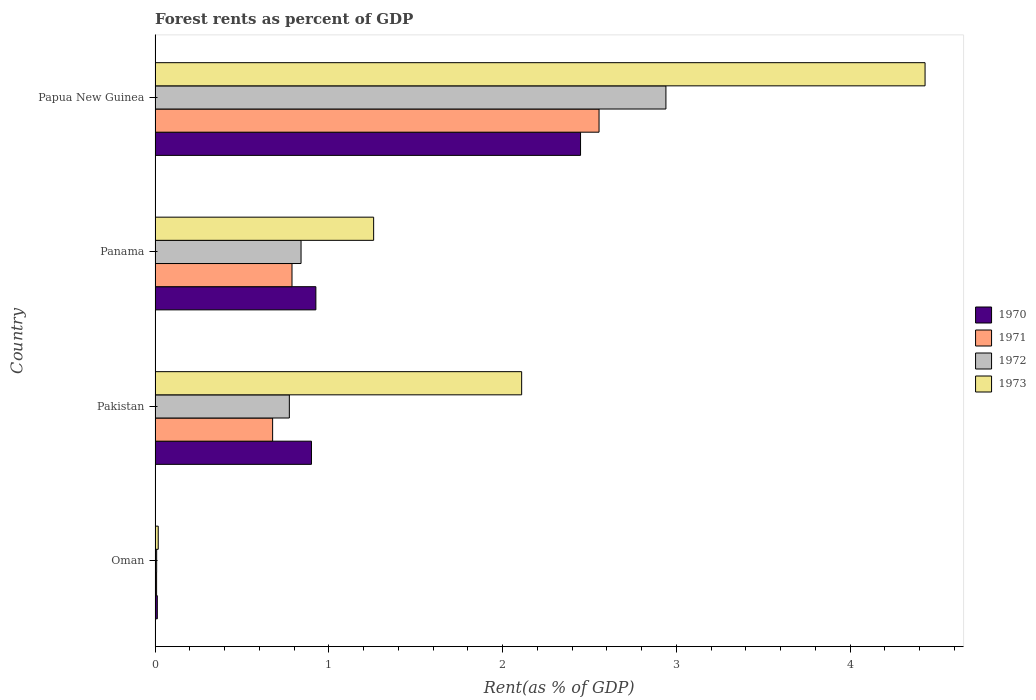How many different coloured bars are there?
Provide a succinct answer. 4. What is the label of the 4th group of bars from the top?
Provide a short and direct response. Oman. In how many cases, is the number of bars for a given country not equal to the number of legend labels?
Make the answer very short. 0. What is the forest rent in 1970 in Pakistan?
Your answer should be compact. 0.9. Across all countries, what is the maximum forest rent in 1972?
Ensure brevity in your answer.  2.94. Across all countries, what is the minimum forest rent in 1971?
Your response must be concise. 0.01. In which country was the forest rent in 1970 maximum?
Give a very brief answer. Papua New Guinea. In which country was the forest rent in 1972 minimum?
Offer a terse response. Oman. What is the total forest rent in 1971 in the graph?
Your response must be concise. 4.03. What is the difference between the forest rent in 1973 in Oman and that in Panama?
Offer a terse response. -1.24. What is the difference between the forest rent in 1973 in Papua New Guinea and the forest rent in 1970 in Oman?
Give a very brief answer. 4.42. What is the average forest rent in 1971 per country?
Ensure brevity in your answer.  1.01. What is the difference between the forest rent in 1973 and forest rent in 1971 in Papua New Guinea?
Ensure brevity in your answer.  1.88. In how many countries, is the forest rent in 1971 greater than 0.2 %?
Ensure brevity in your answer.  3. What is the ratio of the forest rent in 1970 in Panama to that in Papua New Guinea?
Offer a very short reply. 0.38. Is the forest rent in 1972 in Oman less than that in Panama?
Provide a short and direct response. Yes. What is the difference between the highest and the second highest forest rent in 1973?
Offer a terse response. 2.32. What is the difference between the highest and the lowest forest rent in 1970?
Your answer should be compact. 2.44. In how many countries, is the forest rent in 1971 greater than the average forest rent in 1971 taken over all countries?
Make the answer very short. 1. Is the sum of the forest rent in 1972 in Oman and Panama greater than the maximum forest rent in 1970 across all countries?
Keep it short and to the point. No. What does the 4th bar from the top in Pakistan represents?
Ensure brevity in your answer.  1970. What does the 2nd bar from the bottom in Pakistan represents?
Give a very brief answer. 1971. Is it the case that in every country, the sum of the forest rent in 1970 and forest rent in 1971 is greater than the forest rent in 1973?
Your answer should be compact. No. Are the values on the major ticks of X-axis written in scientific E-notation?
Provide a short and direct response. No. How are the legend labels stacked?
Your answer should be compact. Vertical. What is the title of the graph?
Keep it short and to the point. Forest rents as percent of GDP. What is the label or title of the X-axis?
Provide a short and direct response. Rent(as % of GDP). What is the Rent(as % of GDP) in 1970 in Oman?
Make the answer very short. 0.01. What is the Rent(as % of GDP) of 1971 in Oman?
Your answer should be compact. 0.01. What is the Rent(as % of GDP) of 1972 in Oman?
Keep it short and to the point. 0.01. What is the Rent(as % of GDP) of 1973 in Oman?
Your response must be concise. 0.02. What is the Rent(as % of GDP) of 1970 in Pakistan?
Provide a succinct answer. 0.9. What is the Rent(as % of GDP) of 1971 in Pakistan?
Your answer should be very brief. 0.68. What is the Rent(as % of GDP) in 1972 in Pakistan?
Ensure brevity in your answer.  0.77. What is the Rent(as % of GDP) of 1973 in Pakistan?
Offer a terse response. 2.11. What is the Rent(as % of GDP) of 1970 in Panama?
Ensure brevity in your answer.  0.93. What is the Rent(as % of GDP) of 1971 in Panama?
Ensure brevity in your answer.  0.79. What is the Rent(as % of GDP) in 1972 in Panama?
Make the answer very short. 0.84. What is the Rent(as % of GDP) in 1973 in Panama?
Ensure brevity in your answer.  1.26. What is the Rent(as % of GDP) of 1970 in Papua New Guinea?
Keep it short and to the point. 2.45. What is the Rent(as % of GDP) in 1971 in Papua New Guinea?
Ensure brevity in your answer.  2.56. What is the Rent(as % of GDP) of 1972 in Papua New Guinea?
Provide a short and direct response. 2.94. What is the Rent(as % of GDP) of 1973 in Papua New Guinea?
Provide a short and direct response. 4.43. Across all countries, what is the maximum Rent(as % of GDP) of 1970?
Keep it short and to the point. 2.45. Across all countries, what is the maximum Rent(as % of GDP) in 1971?
Your response must be concise. 2.56. Across all countries, what is the maximum Rent(as % of GDP) of 1972?
Provide a short and direct response. 2.94. Across all countries, what is the maximum Rent(as % of GDP) of 1973?
Offer a terse response. 4.43. Across all countries, what is the minimum Rent(as % of GDP) of 1970?
Offer a terse response. 0.01. Across all countries, what is the minimum Rent(as % of GDP) in 1971?
Offer a very short reply. 0.01. Across all countries, what is the minimum Rent(as % of GDP) of 1972?
Keep it short and to the point. 0.01. Across all countries, what is the minimum Rent(as % of GDP) of 1973?
Keep it short and to the point. 0.02. What is the total Rent(as % of GDP) of 1970 in the graph?
Offer a terse response. 4.29. What is the total Rent(as % of GDP) of 1971 in the graph?
Your answer should be compact. 4.03. What is the total Rent(as % of GDP) in 1972 in the graph?
Your response must be concise. 4.56. What is the total Rent(as % of GDP) of 1973 in the graph?
Offer a terse response. 7.82. What is the difference between the Rent(as % of GDP) of 1970 in Oman and that in Pakistan?
Give a very brief answer. -0.89. What is the difference between the Rent(as % of GDP) in 1971 in Oman and that in Pakistan?
Give a very brief answer. -0.67. What is the difference between the Rent(as % of GDP) of 1972 in Oman and that in Pakistan?
Your response must be concise. -0.76. What is the difference between the Rent(as % of GDP) in 1973 in Oman and that in Pakistan?
Offer a terse response. -2.09. What is the difference between the Rent(as % of GDP) in 1970 in Oman and that in Panama?
Your answer should be very brief. -0.91. What is the difference between the Rent(as % of GDP) in 1971 in Oman and that in Panama?
Offer a very short reply. -0.78. What is the difference between the Rent(as % of GDP) in 1972 in Oman and that in Panama?
Your response must be concise. -0.83. What is the difference between the Rent(as % of GDP) of 1973 in Oman and that in Panama?
Give a very brief answer. -1.24. What is the difference between the Rent(as % of GDP) of 1970 in Oman and that in Papua New Guinea?
Make the answer very short. -2.44. What is the difference between the Rent(as % of GDP) of 1971 in Oman and that in Papua New Guinea?
Keep it short and to the point. -2.55. What is the difference between the Rent(as % of GDP) in 1972 in Oman and that in Papua New Guinea?
Give a very brief answer. -2.93. What is the difference between the Rent(as % of GDP) of 1973 in Oman and that in Papua New Guinea?
Your response must be concise. -4.41. What is the difference between the Rent(as % of GDP) of 1970 in Pakistan and that in Panama?
Make the answer very short. -0.03. What is the difference between the Rent(as % of GDP) in 1971 in Pakistan and that in Panama?
Your answer should be very brief. -0.11. What is the difference between the Rent(as % of GDP) of 1972 in Pakistan and that in Panama?
Provide a short and direct response. -0.07. What is the difference between the Rent(as % of GDP) in 1973 in Pakistan and that in Panama?
Ensure brevity in your answer.  0.85. What is the difference between the Rent(as % of GDP) of 1970 in Pakistan and that in Papua New Guinea?
Your answer should be compact. -1.55. What is the difference between the Rent(as % of GDP) of 1971 in Pakistan and that in Papua New Guinea?
Offer a very short reply. -1.88. What is the difference between the Rent(as % of GDP) in 1972 in Pakistan and that in Papua New Guinea?
Your answer should be compact. -2.17. What is the difference between the Rent(as % of GDP) of 1973 in Pakistan and that in Papua New Guinea?
Your answer should be compact. -2.32. What is the difference between the Rent(as % of GDP) in 1970 in Panama and that in Papua New Guinea?
Make the answer very short. -1.52. What is the difference between the Rent(as % of GDP) in 1971 in Panama and that in Papua New Guinea?
Give a very brief answer. -1.77. What is the difference between the Rent(as % of GDP) in 1972 in Panama and that in Papua New Guinea?
Your answer should be very brief. -2.1. What is the difference between the Rent(as % of GDP) of 1973 in Panama and that in Papua New Guinea?
Your answer should be very brief. -3.17. What is the difference between the Rent(as % of GDP) in 1970 in Oman and the Rent(as % of GDP) in 1971 in Pakistan?
Offer a terse response. -0.66. What is the difference between the Rent(as % of GDP) in 1970 in Oman and the Rent(as % of GDP) in 1972 in Pakistan?
Give a very brief answer. -0.76. What is the difference between the Rent(as % of GDP) of 1970 in Oman and the Rent(as % of GDP) of 1973 in Pakistan?
Your answer should be very brief. -2.1. What is the difference between the Rent(as % of GDP) in 1971 in Oman and the Rent(as % of GDP) in 1972 in Pakistan?
Your answer should be compact. -0.76. What is the difference between the Rent(as % of GDP) in 1971 in Oman and the Rent(as % of GDP) in 1973 in Pakistan?
Offer a terse response. -2.1. What is the difference between the Rent(as % of GDP) of 1972 in Oman and the Rent(as % of GDP) of 1973 in Pakistan?
Ensure brevity in your answer.  -2.1. What is the difference between the Rent(as % of GDP) in 1970 in Oman and the Rent(as % of GDP) in 1971 in Panama?
Ensure brevity in your answer.  -0.78. What is the difference between the Rent(as % of GDP) in 1970 in Oman and the Rent(as % of GDP) in 1972 in Panama?
Offer a terse response. -0.83. What is the difference between the Rent(as % of GDP) of 1970 in Oman and the Rent(as % of GDP) of 1973 in Panama?
Give a very brief answer. -1.25. What is the difference between the Rent(as % of GDP) in 1971 in Oman and the Rent(as % of GDP) in 1972 in Panama?
Ensure brevity in your answer.  -0.83. What is the difference between the Rent(as % of GDP) in 1971 in Oman and the Rent(as % of GDP) in 1973 in Panama?
Give a very brief answer. -1.25. What is the difference between the Rent(as % of GDP) in 1972 in Oman and the Rent(as % of GDP) in 1973 in Panama?
Make the answer very short. -1.25. What is the difference between the Rent(as % of GDP) in 1970 in Oman and the Rent(as % of GDP) in 1971 in Papua New Guinea?
Make the answer very short. -2.54. What is the difference between the Rent(as % of GDP) in 1970 in Oman and the Rent(as % of GDP) in 1972 in Papua New Guinea?
Your answer should be very brief. -2.93. What is the difference between the Rent(as % of GDP) of 1970 in Oman and the Rent(as % of GDP) of 1973 in Papua New Guinea?
Offer a very short reply. -4.42. What is the difference between the Rent(as % of GDP) in 1971 in Oman and the Rent(as % of GDP) in 1972 in Papua New Guinea?
Provide a short and direct response. -2.93. What is the difference between the Rent(as % of GDP) in 1971 in Oman and the Rent(as % of GDP) in 1973 in Papua New Guinea?
Your answer should be compact. -4.42. What is the difference between the Rent(as % of GDP) of 1972 in Oman and the Rent(as % of GDP) of 1973 in Papua New Guinea?
Make the answer very short. -4.42. What is the difference between the Rent(as % of GDP) of 1970 in Pakistan and the Rent(as % of GDP) of 1971 in Panama?
Ensure brevity in your answer.  0.11. What is the difference between the Rent(as % of GDP) in 1970 in Pakistan and the Rent(as % of GDP) in 1973 in Panama?
Offer a terse response. -0.36. What is the difference between the Rent(as % of GDP) in 1971 in Pakistan and the Rent(as % of GDP) in 1972 in Panama?
Offer a terse response. -0.16. What is the difference between the Rent(as % of GDP) of 1971 in Pakistan and the Rent(as % of GDP) of 1973 in Panama?
Your answer should be very brief. -0.58. What is the difference between the Rent(as % of GDP) of 1972 in Pakistan and the Rent(as % of GDP) of 1973 in Panama?
Keep it short and to the point. -0.49. What is the difference between the Rent(as % of GDP) in 1970 in Pakistan and the Rent(as % of GDP) in 1971 in Papua New Guinea?
Provide a succinct answer. -1.66. What is the difference between the Rent(as % of GDP) of 1970 in Pakistan and the Rent(as % of GDP) of 1972 in Papua New Guinea?
Keep it short and to the point. -2.04. What is the difference between the Rent(as % of GDP) in 1970 in Pakistan and the Rent(as % of GDP) in 1973 in Papua New Guinea?
Provide a short and direct response. -3.53. What is the difference between the Rent(as % of GDP) of 1971 in Pakistan and the Rent(as % of GDP) of 1972 in Papua New Guinea?
Keep it short and to the point. -2.26. What is the difference between the Rent(as % of GDP) of 1971 in Pakistan and the Rent(as % of GDP) of 1973 in Papua New Guinea?
Your answer should be very brief. -3.76. What is the difference between the Rent(as % of GDP) of 1972 in Pakistan and the Rent(as % of GDP) of 1973 in Papua New Guinea?
Keep it short and to the point. -3.66. What is the difference between the Rent(as % of GDP) in 1970 in Panama and the Rent(as % of GDP) in 1971 in Papua New Guinea?
Your answer should be very brief. -1.63. What is the difference between the Rent(as % of GDP) in 1970 in Panama and the Rent(as % of GDP) in 1972 in Papua New Guinea?
Ensure brevity in your answer.  -2.01. What is the difference between the Rent(as % of GDP) of 1970 in Panama and the Rent(as % of GDP) of 1973 in Papua New Guinea?
Your answer should be compact. -3.51. What is the difference between the Rent(as % of GDP) in 1971 in Panama and the Rent(as % of GDP) in 1972 in Papua New Guinea?
Keep it short and to the point. -2.15. What is the difference between the Rent(as % of GDP) of 1971 in Panama and the Rent(as % of GDP) of 1973 in Papua New Guinea?
Provide a succinct answer. -3.64. What is the difference between the Rent(as % of GDP) of 1972 in Panama and the Rent(as % of GDP) of 1973 in Papua New Guinea?
Give a very brief answer. -3.59. What is the average Rent(as % of GDP) in 1970 per country?
Make the answer very short. 1.07. What is the average Rent(as % of GDP) of 1971 per country?
Your response must be concise. 1.01. What is the average Rent(as % of GDP) of 1972 per country?
Your answer should be compact. 1.14. What is the average Rent(as % of GDP) in 1973 per country?
Make the answer very short. 1.95. What is the difference between the Rent(as % of GDP) of 1970 and Rent(as % of GDP) of 1971 in Oman?
Give a very brief answer. 0. What is the difference between the Rent(as % of GDP) of 1970 and Rent(as % of GDP) of 1972 in Oman?
Give a very brief answer. 0. What is the difference between the Rent(as % of GDP) of 1970 and Rent(as % of GDP) of 1973 in Oman?
Your answer should be very brief. -0.01. What is the difference between the Rent(as % of GDP) in 1971 and Rent(as % of GDP) in 1972 in Oman?
Make the answer very short. -0. What is the difference between the Rent(as % of GDP) of 1971 and Rent(as % of GDP) of 1973 in Oman?
Provide a short and direct response. -0.01. What is the difference between the Rent(as % of GDP) of 1972 and Rent(as % of GDP) of 1973 in Oman?
Provide a short and direct response. -0.01. What is the difference between the Rent(as % of GDP) in 1970 and Rent(as % of GDP) in 1971 in Pakistan?
Your answer should be very brief. 0.22. What is the difference between the Rent(as % of GDP) of 1970 and Rent(as % of GDP) of 1972 in Pakistan?
Your answer should be very brief. 0.13. What is the difference between the Rent(as % of GDP) in 1970 and Rent(as % of GDP) in 1973 in Pakistan?
Provide a succinct answer. -1.21. What is the difference between the Rent(as % of GDP) in 1971 and Rent(as % of GDP) in 1972 in Pakistan?
Offer a very short reply. -0.1. What is the difference between the Rent(as % of GDP) of 1971 and Rent(as % of GDP) of 1973 in Pakistan?
Make the answer very short. -1.43. What is the difference between the Rent(as % of GDP) in 1972 and Rent(as % of GDP) in 1973 in Pakistan?
Offer a terse response. -1.34. What is the difference between the Rent(as % of GDP) of 1970 and Rent(as % of GDP) of 1971 in Panama?
Your answer should be very brief. 0.14. What is the difference between the Rent(as % of GDP) in 1970 and Rent(as % of GDP) in 1972 in Panama?
Provide a short and direct response. 0.09. What is the difference between the Rent(as % of GDP) of 1970 and Rent(as % of GDP) of 1973 in Panama?
Your answer should be very brief. -0.33. What is the difference between the Rent(as % of GDP) of 1971 and Rent(as % of GDP) of 1972 in Panama?
Offer a terse response. -0.05. What is the difference between the Rent(as % of GDP) in 1971 and Rent(as % of GDP) in 1973 in Panama?
Ensure brevity in your answer.  -0.47. What is the difference between the Rent(as % of GDP) of 1972 and Rent(as % of GDP) of 1973 in Panama?
Your response must be concise. -0.42. What is the difference between the Rent(as % of GDP) in 1970 and Rent(as % of GDP) in 1971 in Papua New Guinea?
Provide a short and direct response. -0.11. What is the difference between the Rent(as % of GDP) in 1970 and Rent(as % of GDP) in 1972 in Papua New Guinea?
Your response must be concise. -0.49. What is the difference between the Rent(as % of GDP) of 1970 and Rent(as % of GDP) of 1973 in Papua New Guinea?
Provide a short and direct response. -1.98. What is the difference between the Rent(as % of GDP) in 1971 and Rent(as % of GDP) in 1972 in Papua New Guinea?
Keep it short and to the point. -0.38. What is the difference between the Rent(as % of GDP) in 1971 and Rent(as % of GDP) in 1973 in Papua New Guinea?
Offer a very short reply. -1.88. What is the difference between the Rent(as % of GDP) of 1972 and Rent(as % of GDP) of 1973 in Papua New Guinea?
Provide a succinct answer. -1.49. What is the ratio of the Rent(as % of GDP) of 1970 in Oman to that in Pakistan?
Make the answer very short. 0.01. What is the ratio of the Rent(as % of GDP) in 1971 in Oman to that in Pakistan?
Make the answer very short. 0.01. What is the ratio of the Rent(as % of GDP) of 1972 in Oman to that in Pakistan?
Your answer should be very brief. 0.01. What is the ratio of the Rent(as % of GDP) in 1973 in Oman to that in Pakistan?
Offer a terse response. 0.01. What is the ratio of the Rent(as % of GDP) in 1970 in Oman to that in Panama?
Your response must be concise. 0.01. What is the ratio of the Rent(as % of GDP) in 1971 in Oman to that in Panama?
Provide a short and direct response. 0.01. What is the ratio of the Rent(as % of GDP) of 1972 in Oman to that in Panama?
Give a very brief answer. 0.01. What is the ratio of the Rent(as % of GDP) of 1973 in Oman to that in Panama?
Keep it short and to the point. 0.01. What is the ratio of the Rent(as % of GDP) of 1970 in Oman to that in Papua New Guinea?
Your response must be concise. 0.01. What is the ratio of the Rent(as % of GDP) of 1971 in Oman to that in Papua New Guinea?
Ensure brevity in your answer.  0. What is the ratio of the Rent(as % of GDP) of 1972 in Oman to that in Papua New Guinea?
Make the answer very short. 0. What is the ratio of the Rent(as % of GDP) in 1973 in Oman to that in Papua New Guinea?
Offer a very short reply. 0. What is the ratio of the Rent(as % of GDP) of 1970 in Pakistan to that in Panama?
Your answer should be compact. 0.97. What is the ratio of the Rent(as % of GDP) of 1971 in Pakistan to that in Panama?
Your response must be concise. 0.86. What is the ratio of the Rent(as % of GDP) in 1972 in Pakistan to that in Panama?
Give a very brief answer. 0.92. What is the ratio of the Rent(as % of GDP) of 1973 in Pakistan to that in Panama?
Provide a short and direct response. 1.68. What is the ratio of the Rent(as % of GDP) in 1970 in Pakistan to that in Papua New Guinea?
Ensure brevity in your answer.  0.37. What is the ratio of the Rent(as % of GDP) of 1971 in Pakistan to that in Papua New Guinea?
Your response must be concise. 0.26. What is the ratio of the Rent(as % of GDP) in 1972 in Pakistan to that in Papua New Guinea?
Give a very brief answer. 0.26. What is the ratio of the Rent(as % of GDP) of 1973 in Pakistan to that in Papua New Guinea?
Ensure brevity in your answer.  0.48. What is the ratio of the Rent(as % of GDP) of 1970 in Panama to that in Papua New Guinea?
Keep it short and to the point. 0.38. What is the ratio of the Rent(as % of GDP) of 1971 in Panama to that in Papua New Guinea?
Your answer should be very brief. 0.31. What is the ratio of the Rent(as % of GDP) of 1972 in Panama to that in Papua New Guinea?
Give a very brief answer. 0.29. What is the ratio of the Rent(as % of GDP) in 1973 in Panama to that in Papua New Guinea?
Your answer should be compact. 0.28. What is the difference between the highest and the second highest Rent(as % of GDP) in 1970?
Ensure brevity in your answer.  1.52. What is the difference between the highest and the second highest Rent(as % of GDP) of 1971?
Give a very brief answer. 1.77. What is the difference between the highest and the second highest Rent(as % of GDP) of 1973?
Keep it short and to the point. 2.32. What is the difference between the highest and the lowest Rent(as % of GDP) in 1970?
Your answer should be very brief. 2.44. What is the difference between the highest and the lowest Rent(as % of GDP) in 1971?
Provide a short and direct response. 2.55. What is the difference between the highest and the lowest Rent(as % of GDP) in 1972?
Provide a succinct answer. 2.93. What is the difference between the highest and the lowest Rent(as % of GDP) of 1973?
Your answer should be very brief. 4.41. 